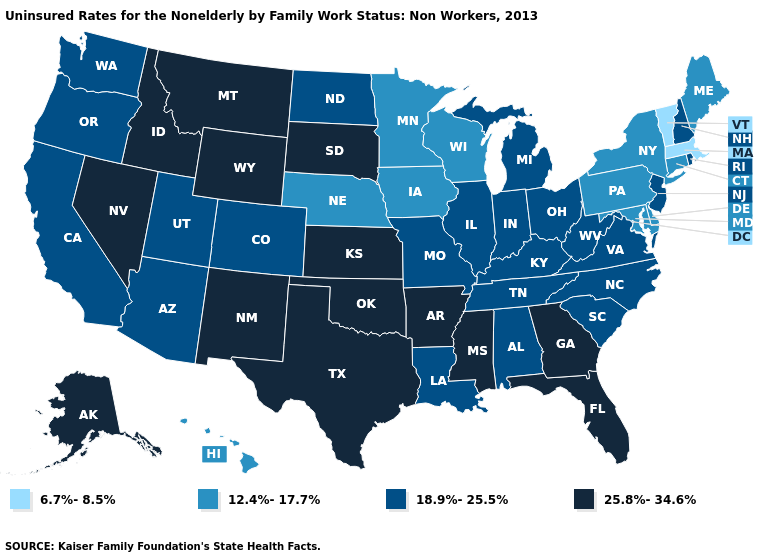Name the states that have a value in the range 25.8%-34.6%?
Give a very brief answer. Alaska, Arkansas, Florida, Georgia, Idaho, Kansas, Mississippi, Montana, Nevada, New Mexico, Oklahoma, South Dakota, Texas, Wyoming. Does Ohio have a lower value than Pennsylvania?
Answer briefly. No. What is the value of Missouri?
Write a very short answer. 18.9%-25.5%. What is the value of Arizona?
Short answer required. 18.9%-25.5%. Which states have the lowest value in the Northeast?
Be succinct. Massachusetts, Vermont. Name the states that have a value in the range 18.9%-25.5%?
Answer briefly. Alabama, Arizona, California, Colorado, Illinois, Indiana, Kentucky, Louisiana, Michigan, Missouri, New Hampshire, New Jersey, North Carolina, North Dakota, Ohio, Oregon, Rhode Island, South Carolina, Tennessee, Utah, Virginia, Washington, West Virginia. Does New York have the lowest value in the Northeast?
Keep it brief. No. Name the states that have a value in the range 25.8%-34.6%?
Concise answer only. Alaska, Arkansas, Florida, Georgia, Idaho, Kansas, Mississippi, Montana, Nevada, New Mexico, Oklahoma, South Dakota, Texas, Wyoming. What is the value of Indiana?
Keep it brief. 18.9%-25.5%. What is the lowest value in the USA?
Be succinct. 6.7%-8.5%. What is the value of Colorado?
Answer briefly. 18.9%-25.5%. What is the lowest value in the USA?
Quick response, please. 6.7%-8.5%. What is the value of Michigan?
Write a very short answer. 18.9%-25.5%. What is the value of Idaho?
Write a very short answer. 25.8%-34.6%. 